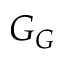<formula> <loc_0><loc_0><loc_500><loc_500>G _ { G }</formula> 